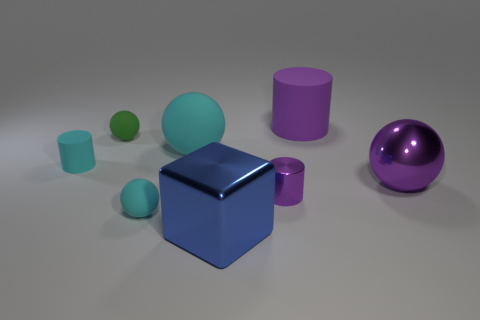What textures do these objects appear to have? The objects in the image seem to have a smooth and slightly reflective surface, suggesting they might be made out of materials like plastic or polished metal. The lighting in the scene creates subtle highlights and shadows that enhance the textural appearance of these geometric forms. 